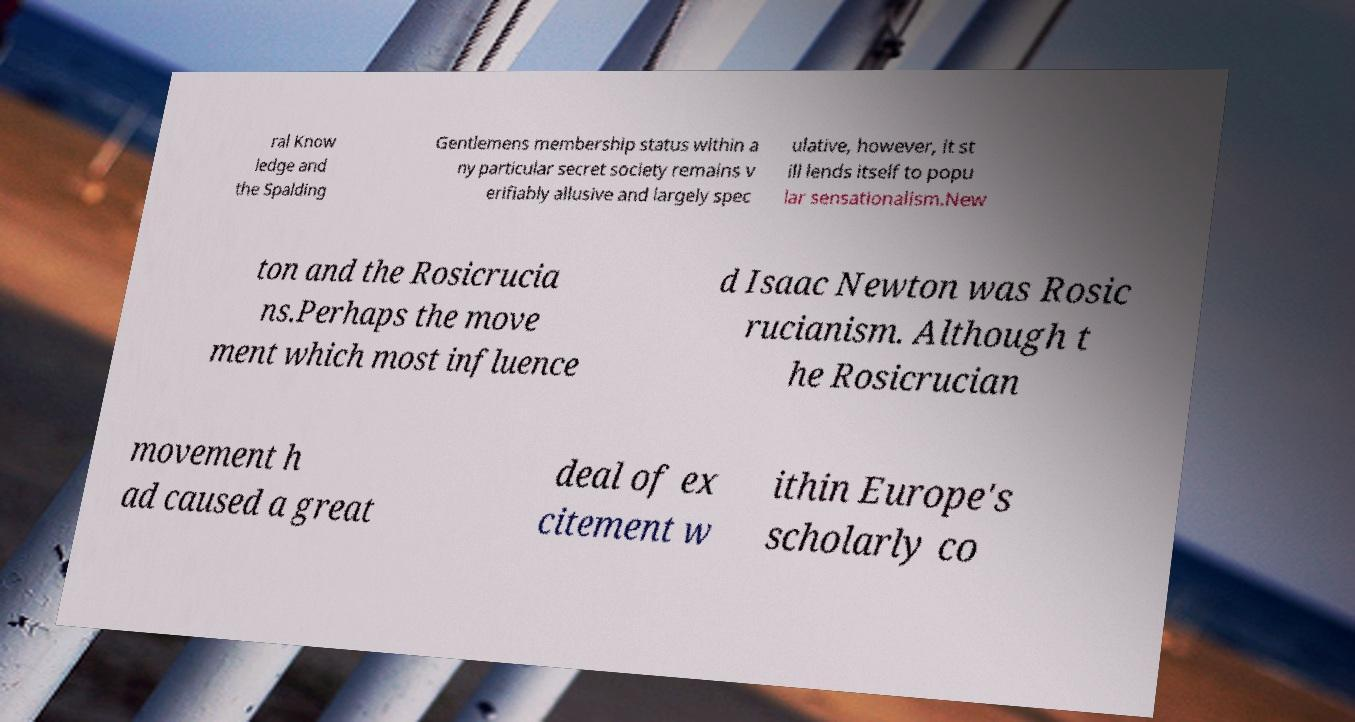I need the written content from this picture converted into text. Can you do that? ral Know ledge and the Spalding Gentlemens membership status within a ny particular secret society remains v erifiably allusive and largely spec ulative, however, it st ill lends itself to popu lar sensationalism.New ton and the Rosicrucia ns.Perhaps the move ment which most influence d Isaac Newton was Rosic rucianism. Although t he Rosicrucian movement h ad caused a great deal of ex citement w ithin Europe's scholarly co 